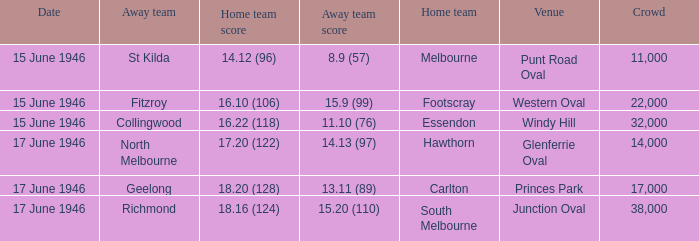Which home team has a home team 14.12 (96)? Melbourne. 